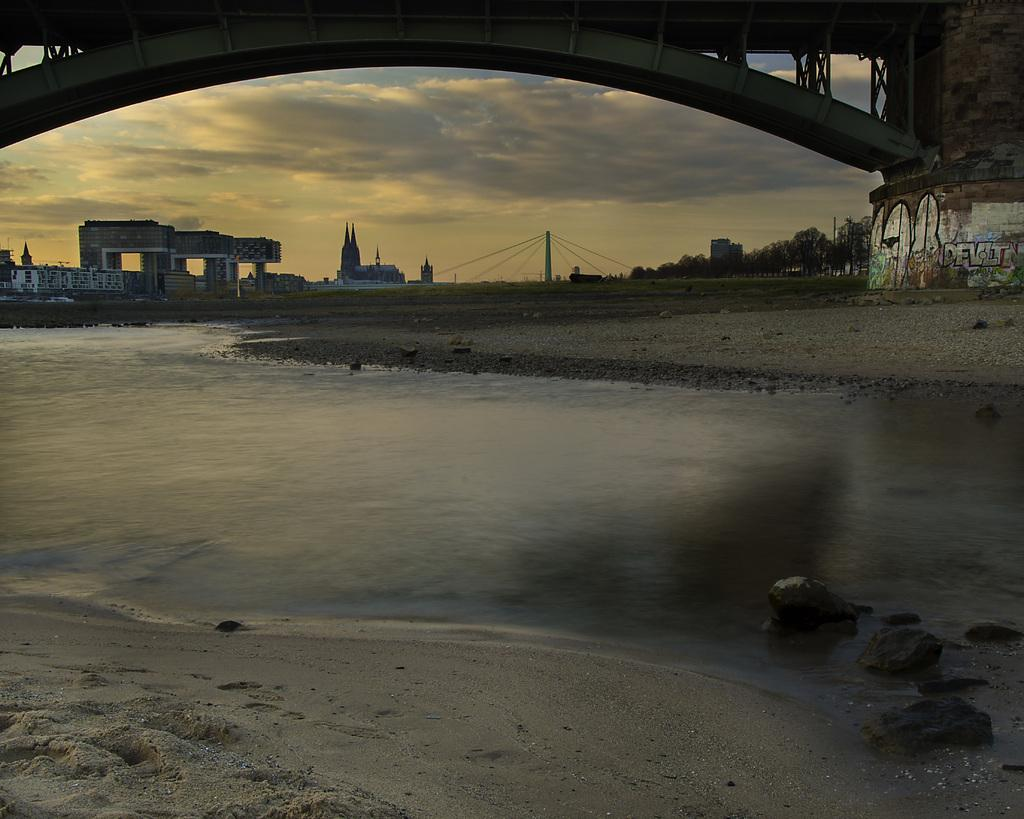What is the primary element visible in the image? There is water in the image. What else can be seen besides the water? There is ground visible in the image, as well as a bridge. What is visible in the background of the image? There are buildings, trees, and the sky visible in the background of the image. What type of appliance can be seen floating in the water in the image? There is no appliance visible in the water in the image. Is there a river present in the image? The image does not specify whether the water is a river or not; it only states that there is water visible. 